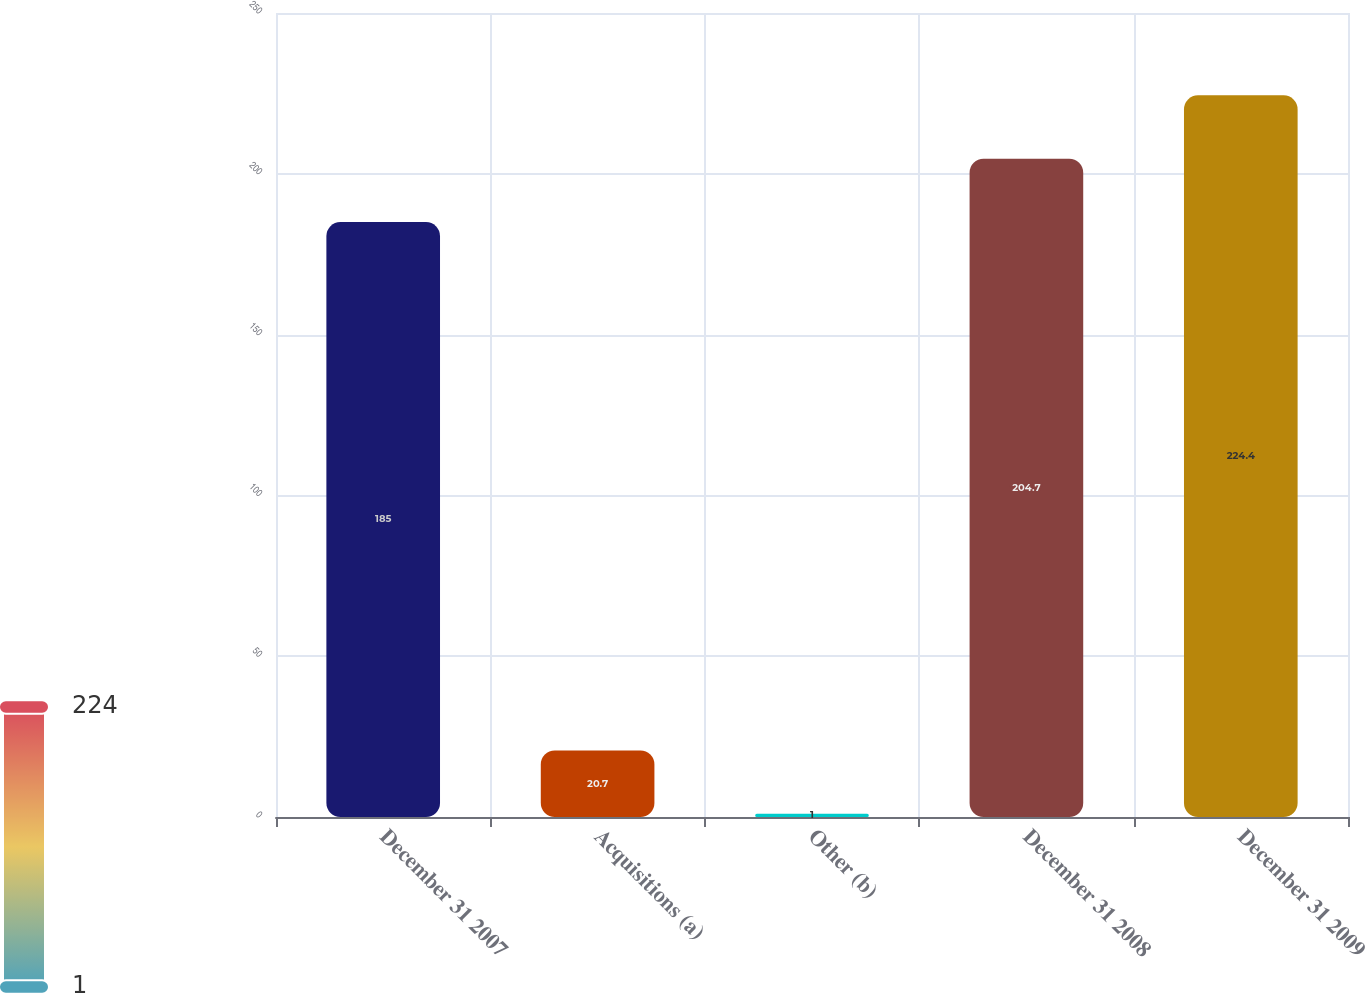<chart> <loc_0><loc_0><loc_500><loc_500><bar_chart><fcel>December 31 2007<fcel>Acquisitions (a)<fcel>Other (b)<fcel>December 31 2008<fcel>December 31 2009<nl><fcel>185<fcel>20.7<fcel>1<fcel>204.7<fcel>224.4<nl></chart> 